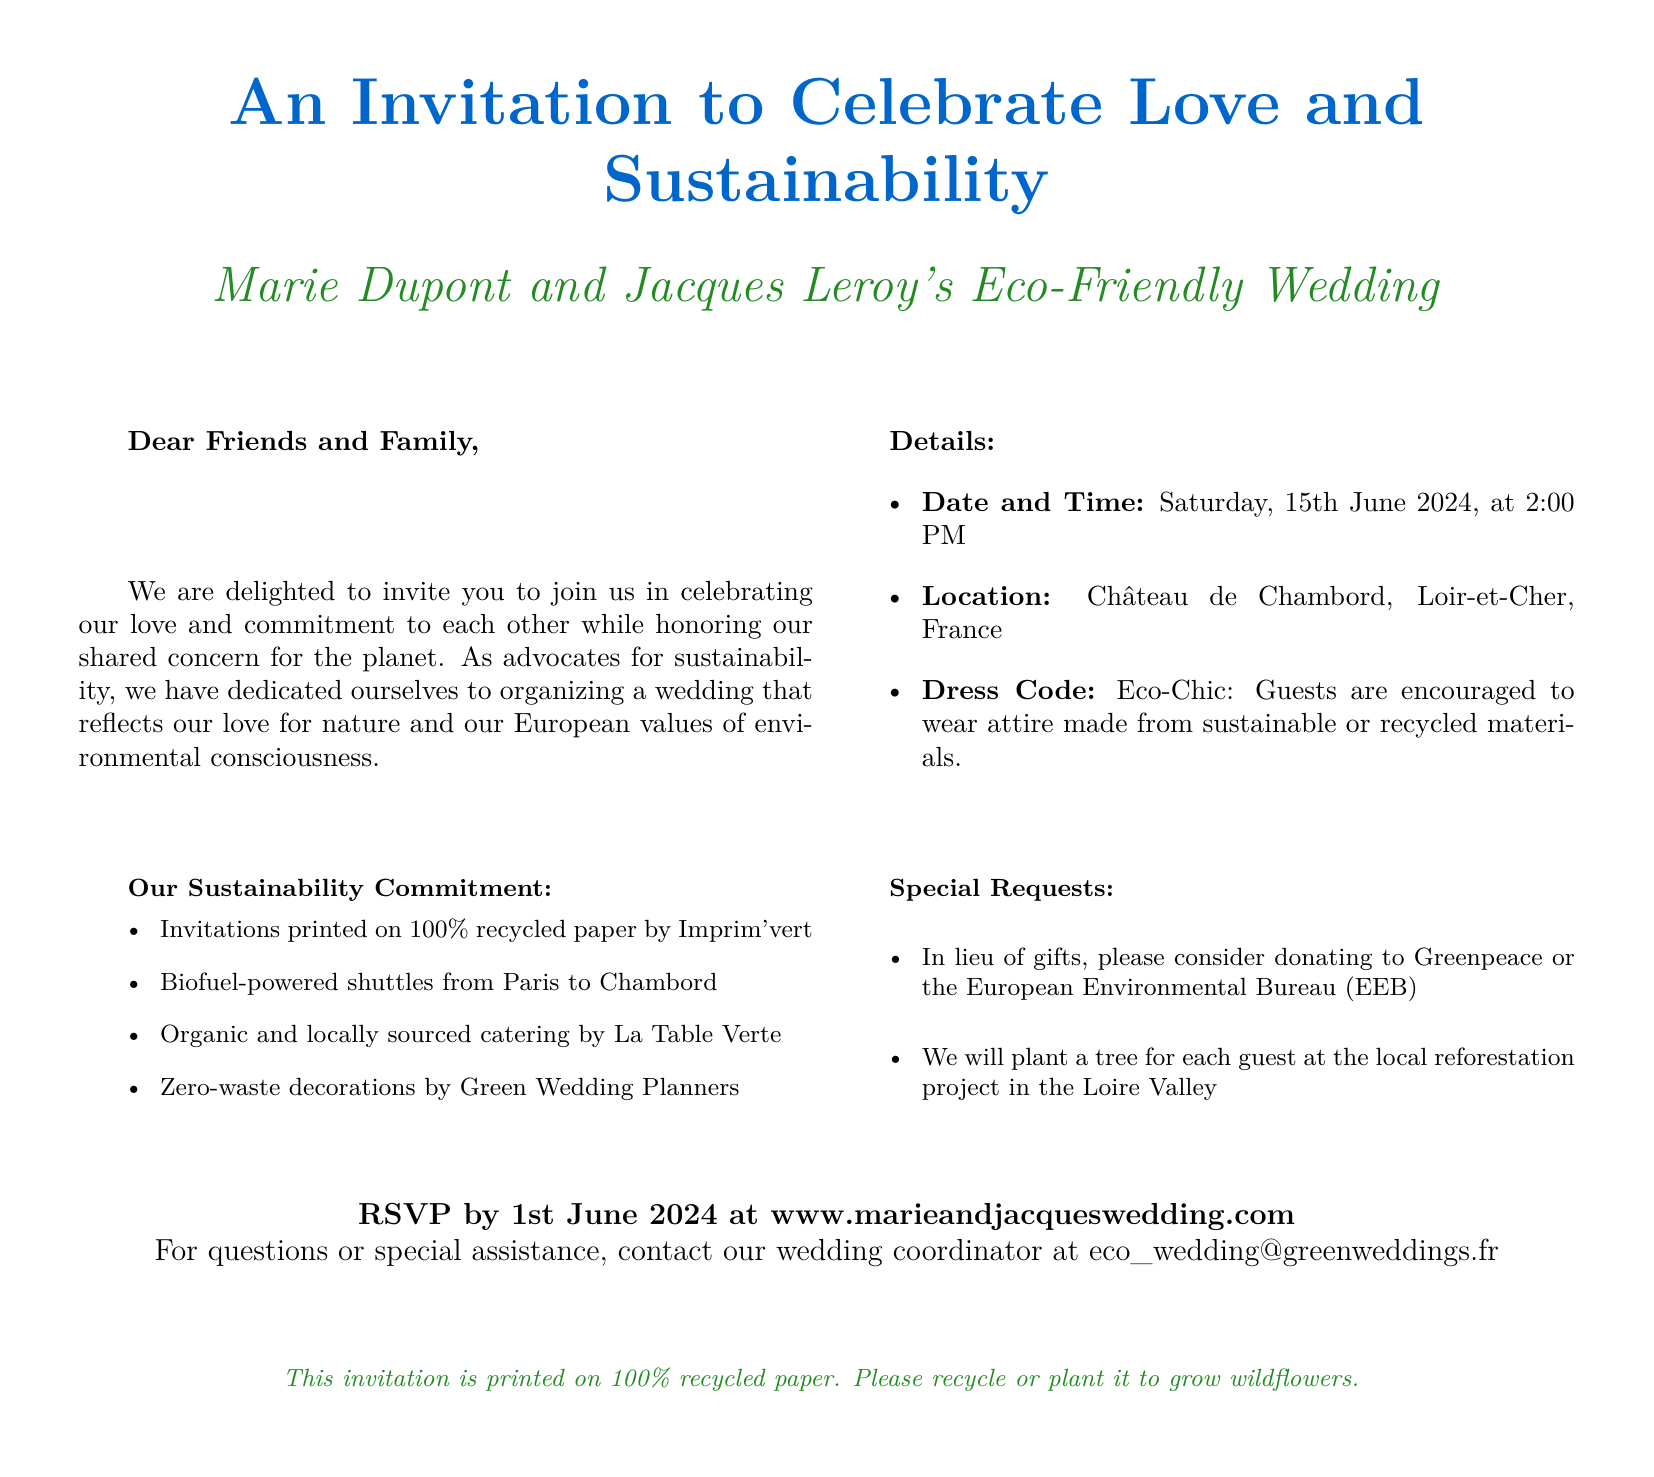What is the date of the wedding? The date of the wedding is specified in the invitation as Saturday, 15th June 2024.
Answer: 15th June 2024 Who are the couple getting married? The invitation mentions the names of the couple as Marie Dupont and Jacques Leroy.
Answer: Marie Dupont and Jacques Leroy What is the location of the wedding? The invitation details the location as Château de Chambord, Loir-et-Cher, France.
Answer: Château de Chambord What type of attire is encouraged for guests? The invitation specifies the dress code as Eco-Chic, encouraging sustainable or recycled attire.
Answer: Eco-Chic What is one method of transportation mentioned for guests? The wedding invitation states that biofuel-powered shuttles will be provided from Paris to Chambord.
Answer: Biofuel-powered shuttles What will the couple do for each guest in terms of environmental commitment? The document notes that a tree will be planted for each guest at a local reforestation project.
Answer: Plant a tree What is the RSVP deadline for the wedding? The invitation indicates that the RSVP should be completed by 1st June 2024.
Answer: 1st June 2024 What type of paper is used for the wedding invitations? The invitation states that the invitations are printed on 100% recycled paper.
Answer: 100% recycled paper Which organization is mentioned for donations in lieu of gifts? The couple requests donations to Greenpeace or the European Environmental Bureau (EEB).
Answer: Greenpeace or the European Environmental Bureau (EEB) 